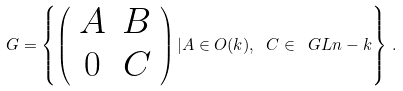Convert formula to latex. <formula><loc_0><loc_0><loc_500><loc_500>G = \left \{ \left ( \begin{array} { c c } A & B \\ 0 & C \end{array} \right ) | A \in O ( k ) , \ C \in \ G L { n - k } \right \} \, .</formula> 